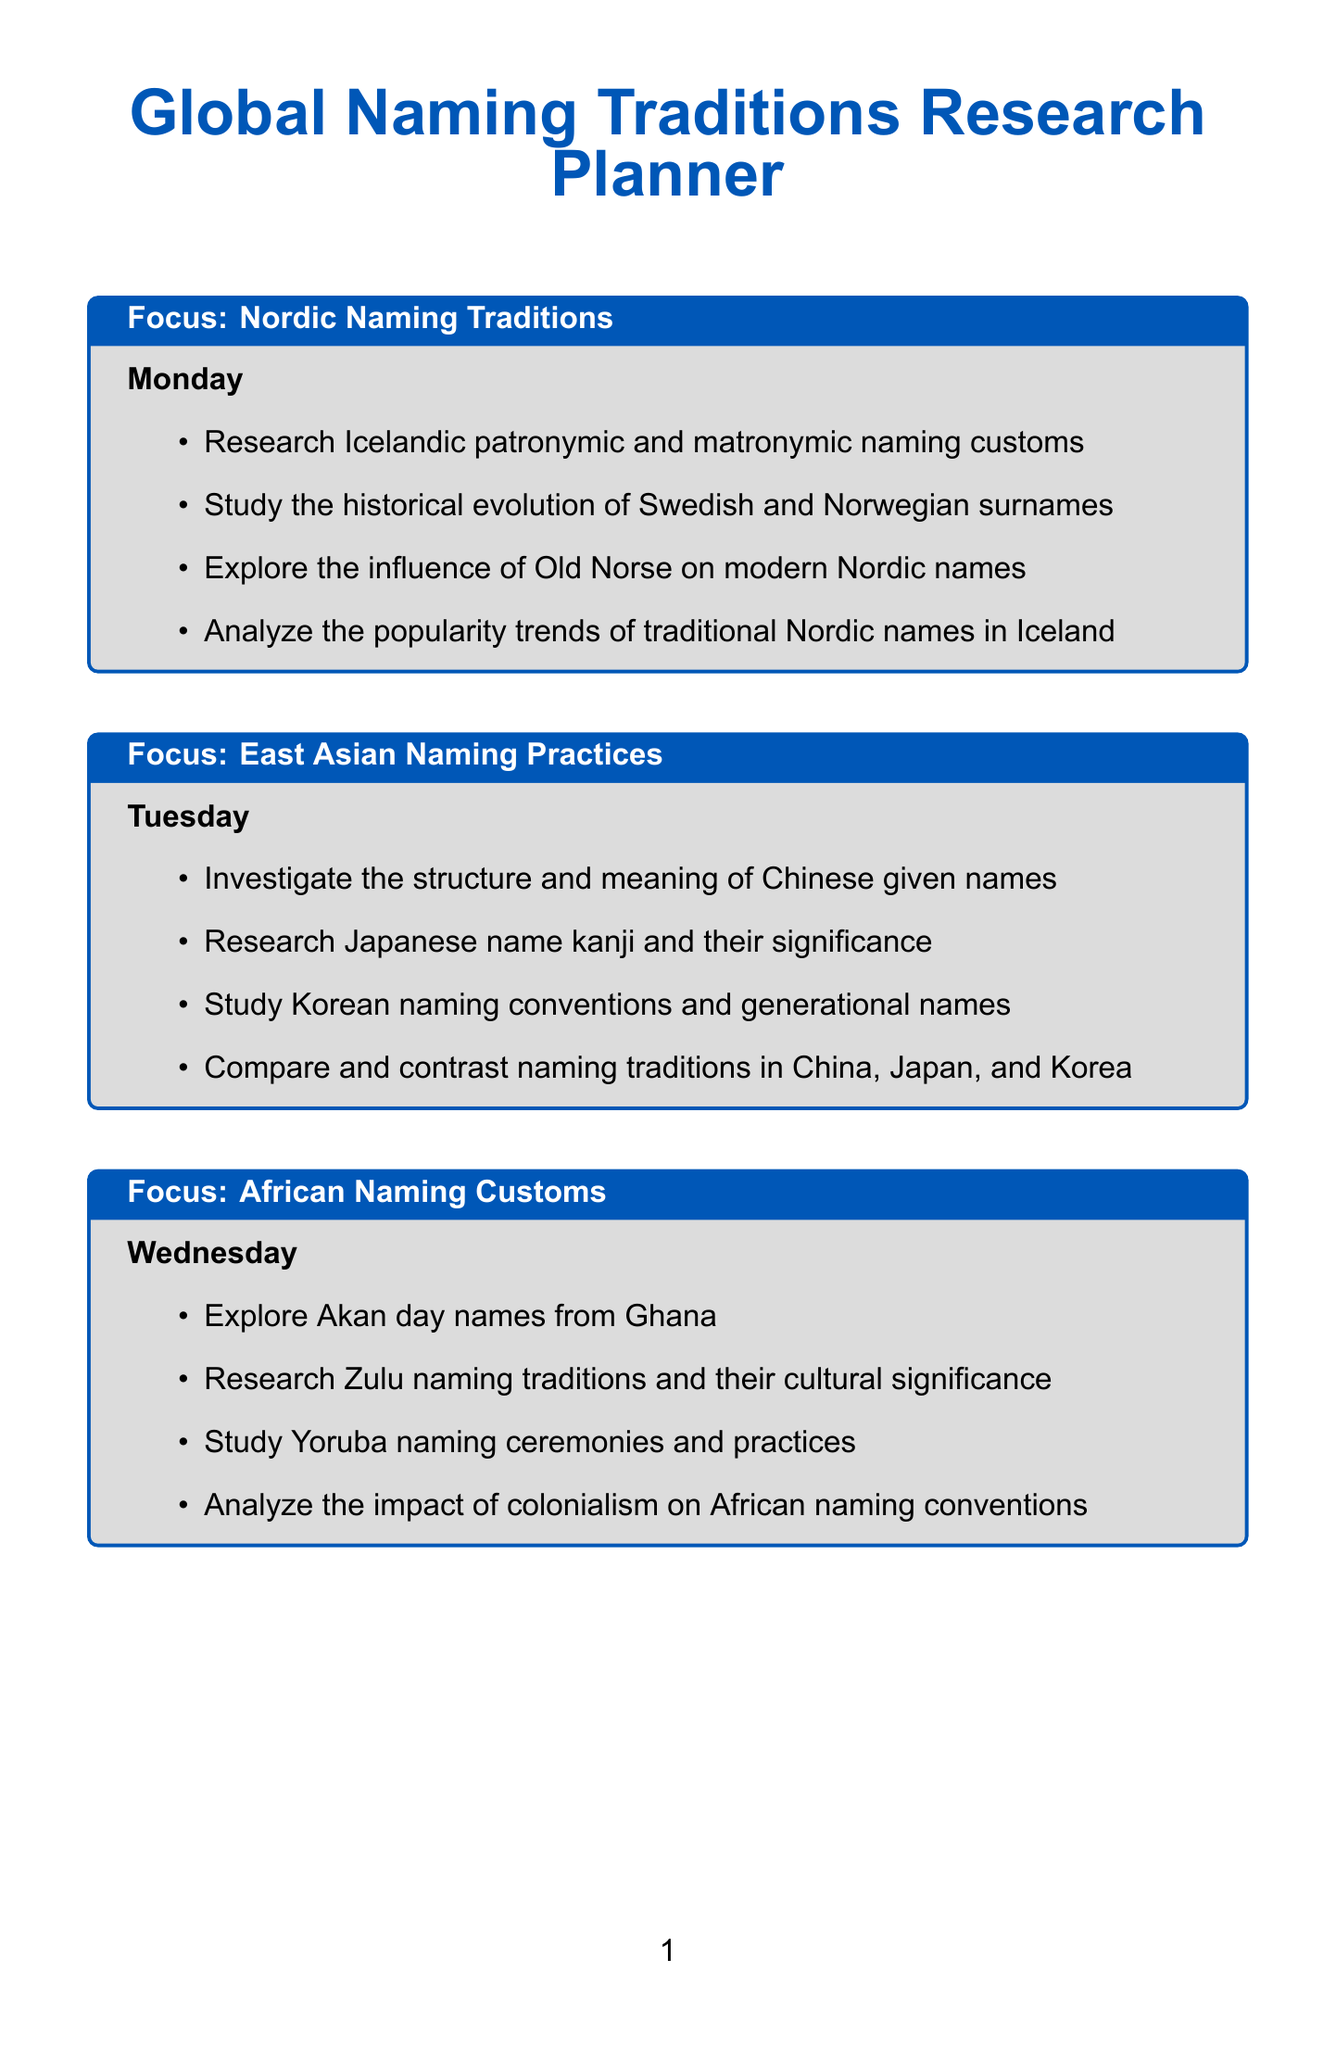What is the focus area for Monday? The focus area for Monday is specified in the document as Nordic Naming Traditions.
Answer: Nordic Naming Traditions How many activities are listed for Saturday? There are four activities listed for Saturday under the European Naming Traditions focus area.
Answer: 4 What cultural tradition is explored on Wednesday? Wednesday focuses on African Naming Customs, which includes various cultural naming traditions.
Answer: African Naming Customs Which naming practices are investigated on Tuesday? Tuesday focuses on East Asian Naming Practices, including Chinese, Japanese, and Korean naming conventions.
Answer: East Asian Naming Practices What is included in the Sunday activities? The Sunday activities focus on analyzing global trends and comparisons in naming practices.
Answer: Global Naming Trends and Comparisons Which culture's naming conventions are studied on Friday? Friday is dedicated to researching Native American naming practices and related customs.
Answer: Native American What is one activity related to Arabic naming traditions? One activity is to investigate Arabic naming patterns and patronymics on Thursday.
Answer: Arabic naming patterns and patronymics Which day includes the study of Persian name elements? The study of Persian name elements occurs on Thursday under Middle Eastern Naming Traditions.
Answer: Thursday What unique aspect of Ghanaian culture is explored on Wednesday? The activities include exploring Akan day names from Ghana, which highlight a unique aspect of their culture.
Answer: Akan day names 